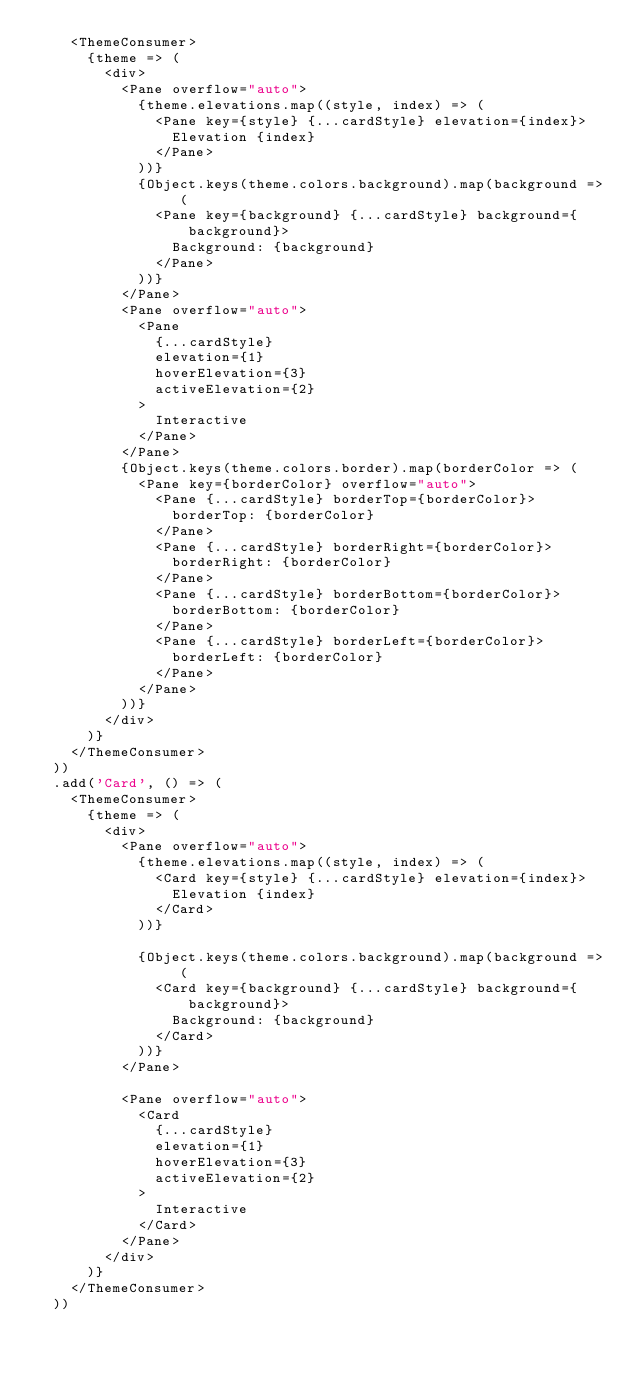<code> <loc_0><loc_0><loc_500><loc_500><_JavaScript_>    <ThemeConsumer>
      {theme => (
        <div>
          <Pane overflow="auto">
            {theme.elevations.map((style, index) => (
              <Pane key={style} {...cardStyle} elevation={index}>
                Elevation {index}
              </Pane>
            ))}
            {Object.keys(theme.colors.background).map(background => (
              <Pane key={background} {...cardStyle} background={background}>
                Background: {background}
              </Pane>
            ))}
          </Pane>
          <Pane overflow="auto">
            <Pane
              {...cardStyle}
              elevation={1}
              hoverElevation={3}
              activeElevation={2}
            >
              Interactive
            </Pane>
          </Pane>
          {Object.keys(theme.colors.border).map(borderColor => (
            <Pane key={borderColor} overflow="auto">
              <Pane {...cardStyle} borderTop={borderColor}>
                borderTop: {borderColor}
              </Pane>
              <Pane {...cardStyle} borderRight={borderColor}>
                borderRight: {borderColor}
              </Pane>
              <Pane {...cardStyle} borderBottom={borderColor}>
                borderBottom: {borderColor}
              </Pane>
              <Pane {...cardStyle} borderLeft={borderColor}>
                borderLeft: {borderColor}
              </Pane>
            </Pane>
          ))}
        </div>
      )}
    </ThemeConsumer>
  ))
  .add('Card', () => (
    <ThemeConsumer>
      {theme => (
        <div>
          <Pane overflow="auto">
            {theme.elevations.map((style, index) => (
              <Card key={style} {...cardStyle} elevation={index}>
                Elevation {index}
              </Card>
            ))}

            {Object.keys(theme.colors.background).map(background => (
              <Card key={background} {...cardStyle} background={background}>
                Background: {background}
              </Card>
            ))}
          </Pane>

          <Pane overflow="auto">
            <Card
              {...cardStyle}
              elevation={1}
              hoverElevation={3}
              activeElevation={2}
            >
              Interactive
            </Card>
          </Pane>
        </div>
      )}
    </ThemeConsumer>
  ))
</code> 